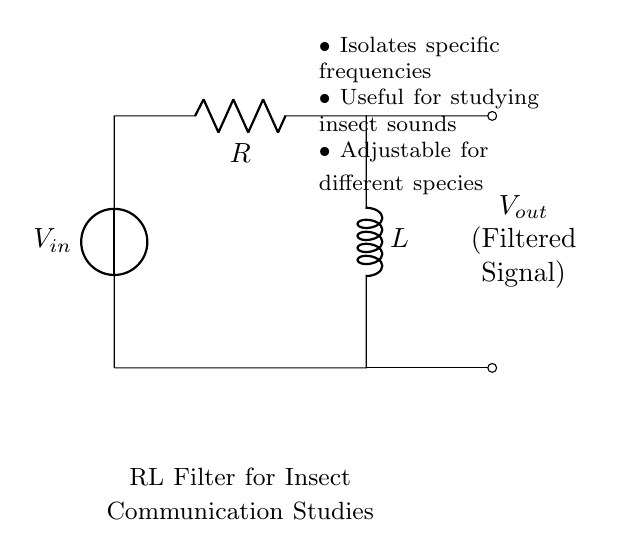What is the input voltage of the circuit? The input voltage is labeled as V_in on the diagram, indicating where the voltage source connects to the circuit.
Answer: V_in What elements are included in this circuit? The circuit consists of a voltage source (V_in), a resistor (R), and an inductor (L), all connected in a loop.
Answer: Voltage source, resistor, inductor What does the output signal represent? The output signal, labeled as V_out, represents the filtered sound frequencies after passing through the RL filter.
Answer: Filtered signal Why is a resistor used in this RL filter circuit? The resistor limits the current and influences the time constant of the RL circuit, which is crucial for filtering specific sound frequencies effectively.
Answer: To limit current What effect does increasing the inductance L have on the filter's frequency response? Increasing the inductance L effectively lowers the cutoff frequency of the filter, allowing only lower frequencies to pass through while attenuating higher frequencies. This is based on the relationship between inductance, resistance, and frequency in an RL circuit.
Answer: Lowers cutoff frequency What is the purpose of this RL filter in insect communication studies? The RL filter isolates specific frequencies that are important for studying insect sounds, enabling researchers to focus on relevant communication signals among insect species.
Answer: Isolates specific frequencies 